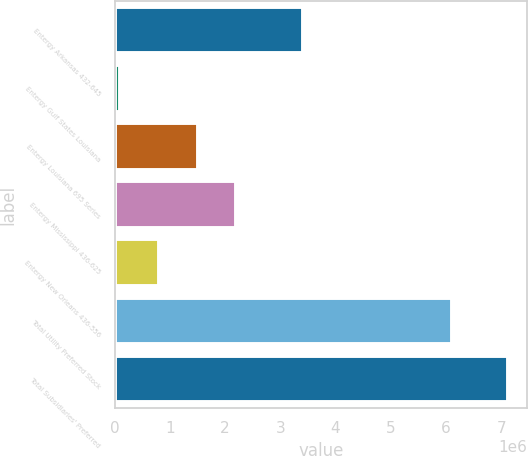Convert chart to OTSL. <chart><loc_0><loc_0><loc_500><loc_500><bar_chart><fcel>Entergy Arkansas 432-645<fcel>Entergy Gulf States Louisiana<fcel>Entergy Louisiana 695 Series<fcel>Entergy Mississippi 436-625<fcel>Entergy New Orleans 436-556<fcel>Total Utility Preferred Stock<fcel>Total Subsidiaries' Preferred<nl><fcel>3.4135e+06<fcel>100000<fcel>1.50302e+06<fcel>2.20453e+06<fcel>801510<fcel>6.1151e+06<fcel>7.1151e+06<nl></chart> 